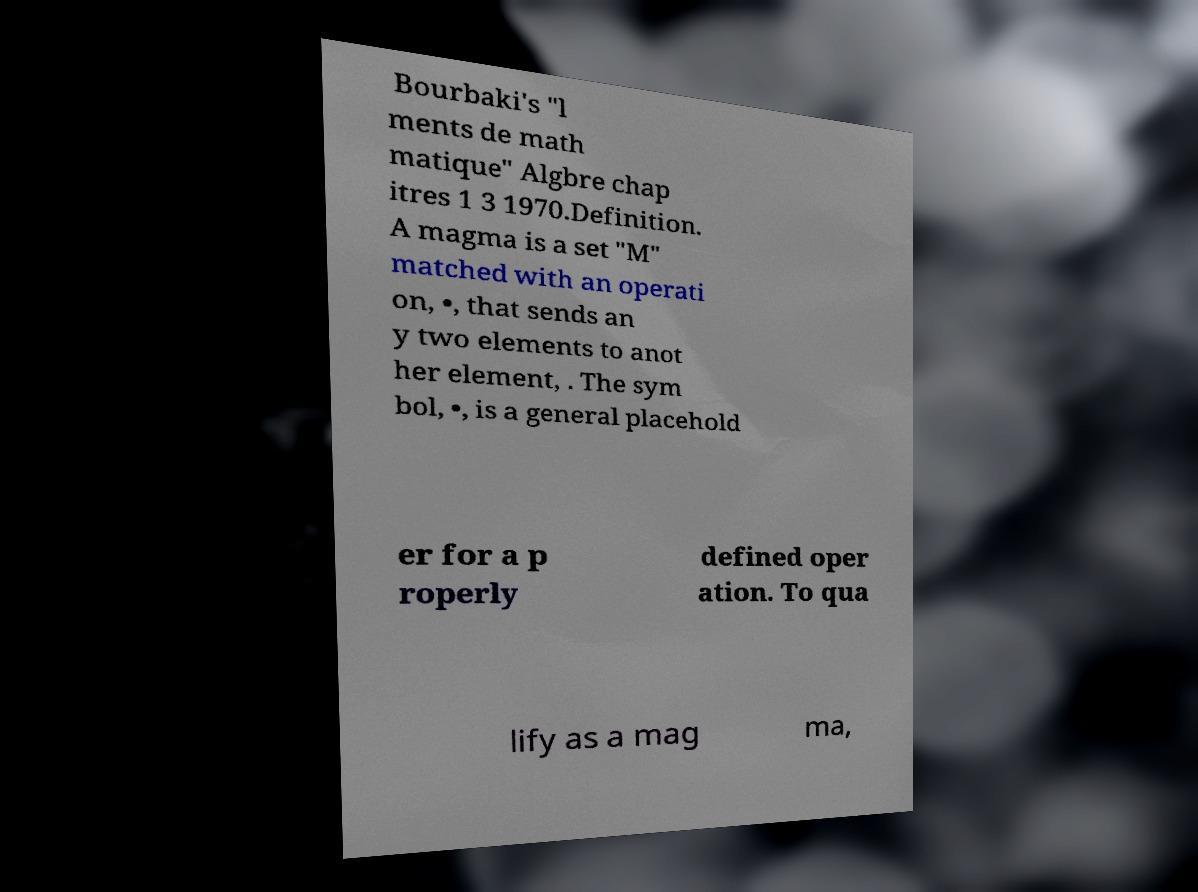I need the written content from this picture converted into text. Can you do that? Bourbaki's "l ments de math matique" Algbre chap itres 1 3 1970.Definition. A magma is a set "M" matched with an operati on, •, that sends an y two elements to anot her element, . The sym bol, •, is a general placehold er for a p roperly defined oper ation. To qua lify as a mag ma, 